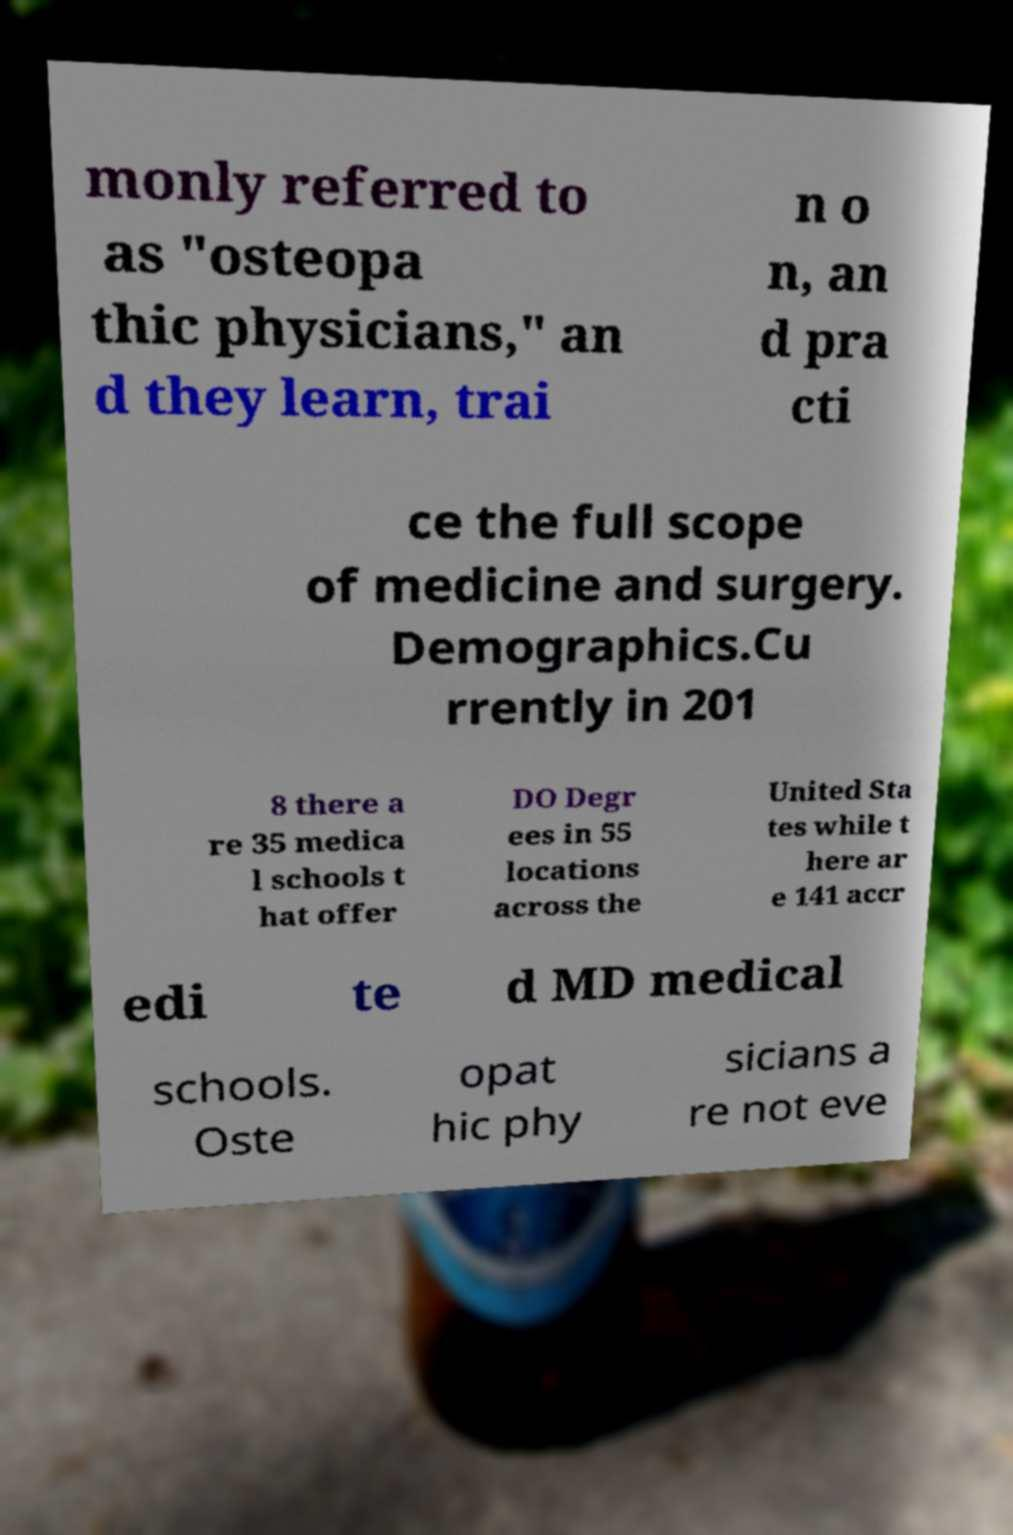Please read and relay the text visible in this image. What does it say? monly referred to as "osteopa thic physicians," an d they learn, trai n o n, an d pra cti ce the full scope of medicine and surgery. Demographics.Cu rrently in 201 8 there a re 35 medica l schools t hat offer DO Degr ees in 55 locations across the United Sta tes while t here ar e 141 accr edi te d MD medical schools. Oste opat hic phy sicians a re not eve 